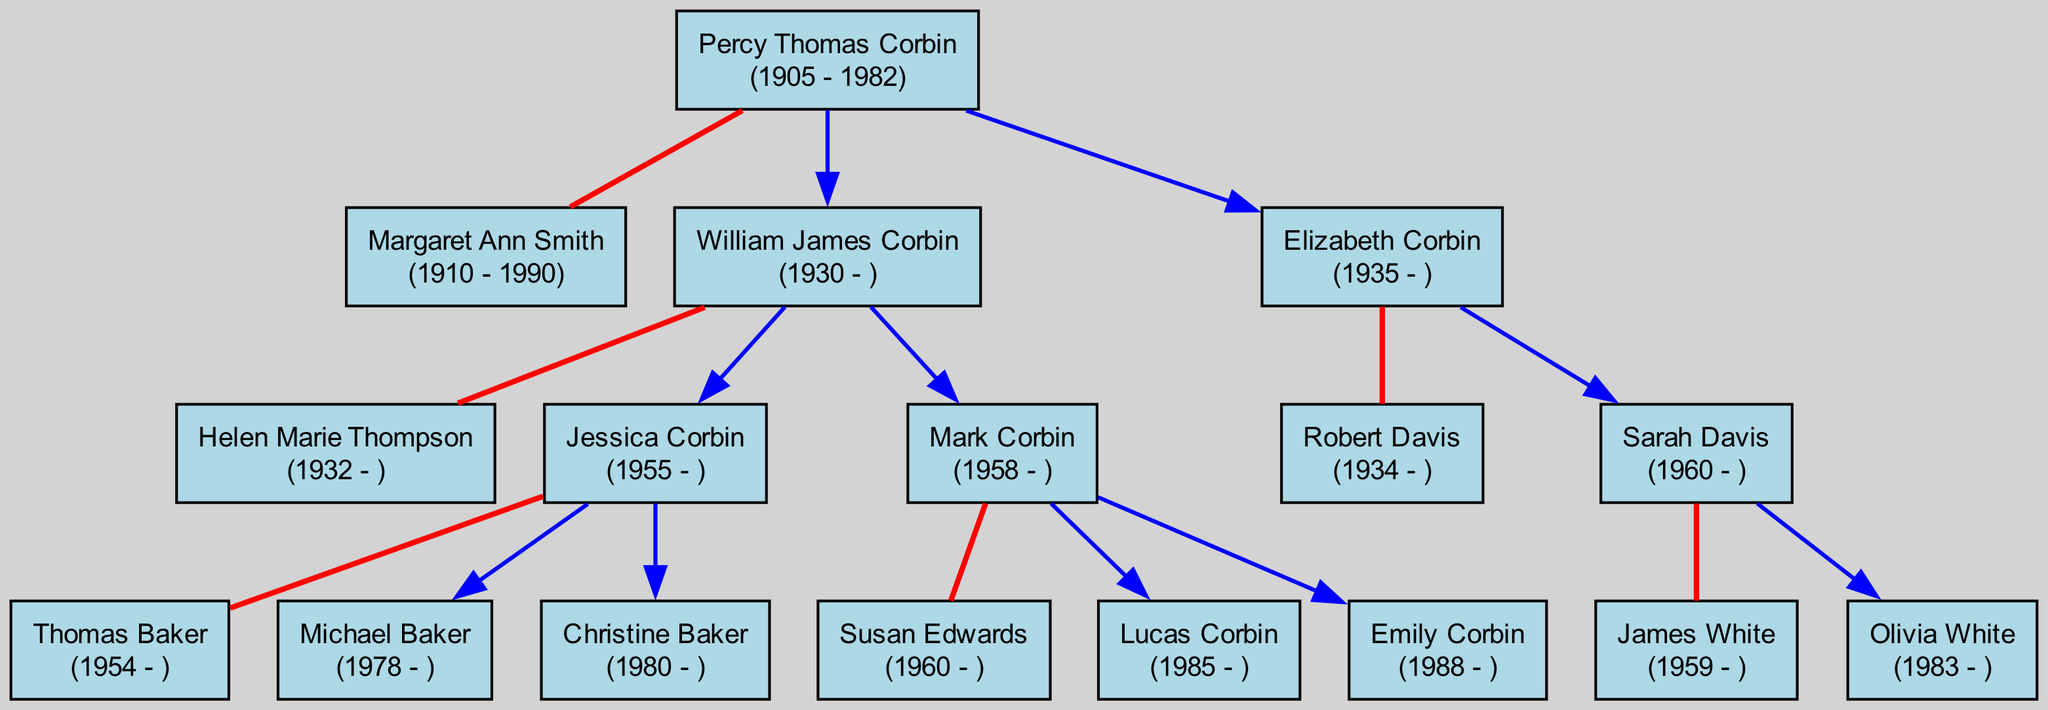What is the birth year of Percy Thomas Corbin? Looking at the diagram, Percy Thomas Corbin's birth year is stated directly beside his name. This can be verified by locating his node in the diagram.
Answer: 1905 How many children did Percy Thomas Corbin have? By examining the diagram, Percy Thomas Corbin has two children listed under his node. Counting these children gives the total.
Answer: 2 What is the name of William James Corbin’s spouse? The diagram shows that William James Corbin's spouse is connected to him with a red line, and her name is provided within her node.
Answer: Helen Marie Thompson Who is the grandchild of Percy Thomas Corbin born in 1985? To find the grandchild born in 1985, we can navigate the diagram from Percy Thomas Corbin's node to his children and then to their children, locating the relevant birth year. The child with that birth year is directly labeled in the diagram.
Answer: Lucas Corbin What is the relationship between Elizabeth Corbin and Robert Davis? The diagram illustrates Elizabeth Corbin and Robert Davis in connected nodes with a marriage line (red line) indicating their relationship. This clearly shows they are spouses.
Answer: Spouses How many grandchildren does William James Corbin have? By inspecting William James Corbin's node and looking at the children listed under him, we can count the number of nodes connected to him by his children, each of whom has their own children labeled in the diagram.
Answer: 4 What is the birth year of Sarah Davis? The diagram displays Sarah Davis' node connected to Elizabeth Corbin, with her birth year clearly stated next to her name. By locating her node, we can directly find her birth year listed.
Answer: 1960 Which child of Percy Thomas Corbin has a spouse named Robert Davis? The step to find this involves first locating Percy Thomas Corbin's children on the diagram, looking closely at their nodes, and identifying which one has an associated spouse named Robert Davis. The relationship line can help us confirm this.
Answer: Elizabeth Corbin How many generations are represented in the diagram? Tracing from Percy Thomas Corbin at the root node to his children (first generation) and then to his grandchildren (second generation), we can also see that his great-grandchildren appear (third generation). Counting from the root to the last generation gives us the total.
Answer: 3 